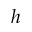Convert formula to latex. <formula><loc_0><loc_0><loc_500><loc_500>h</formula> 